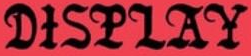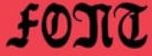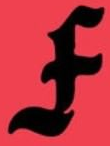What words are shown in these images in order, separated by a semicolon? DISPLAY; FONT; F 